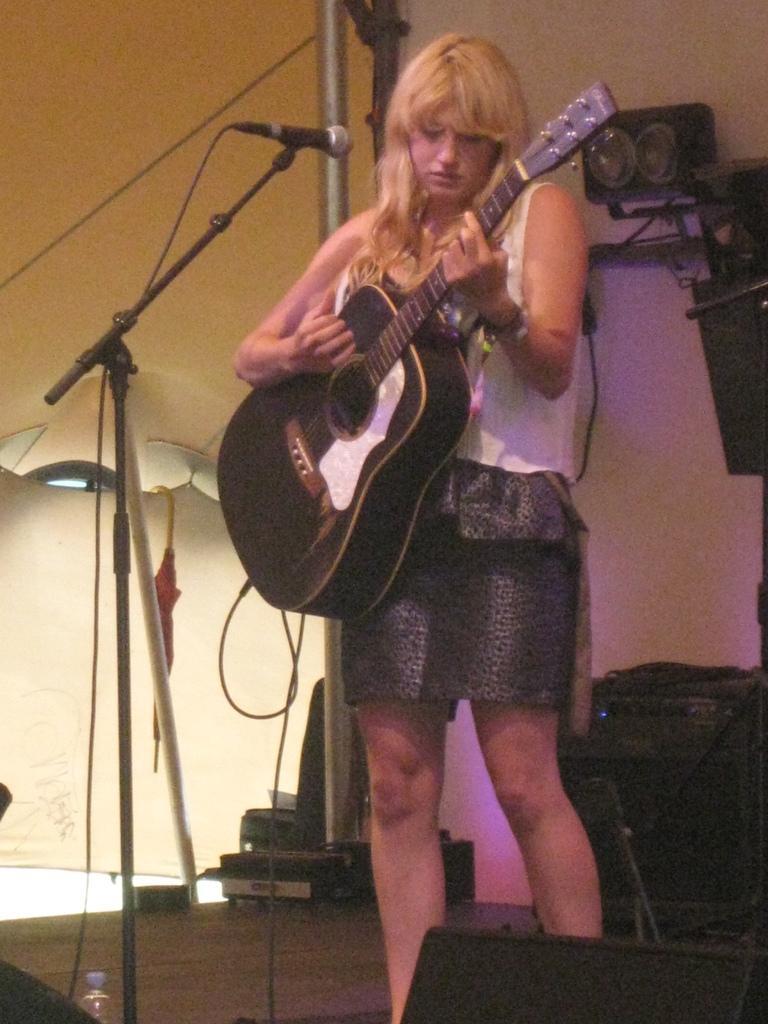Please provide a concise description of this image. In the picture I can see a woman standing on the wooden floor and she is playing a guitar. I can see a microphone on the stand. 